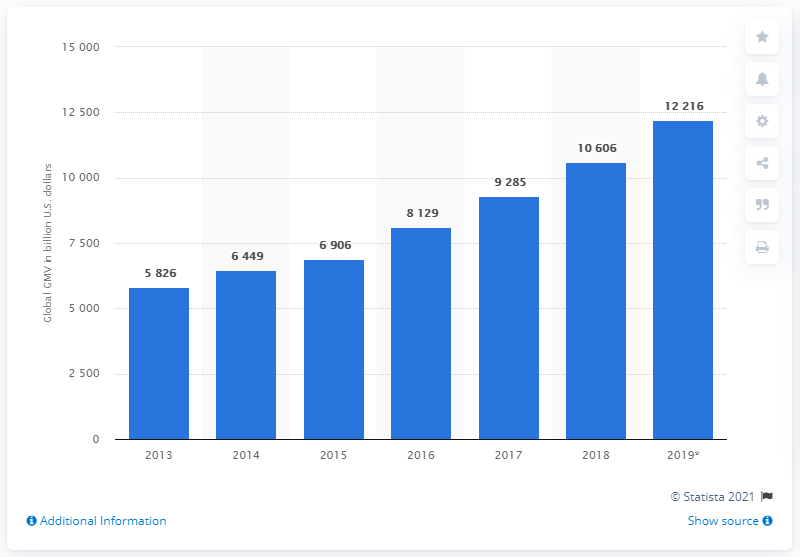Mention a couple of crucial points in this snapshot. The projected gross merchandise volume of B2B e-commerce transactions in 2019 is expected to reach 12,216. In 2013, the gross merchandise volume of B2B e-commerce transactions was 5,826. 